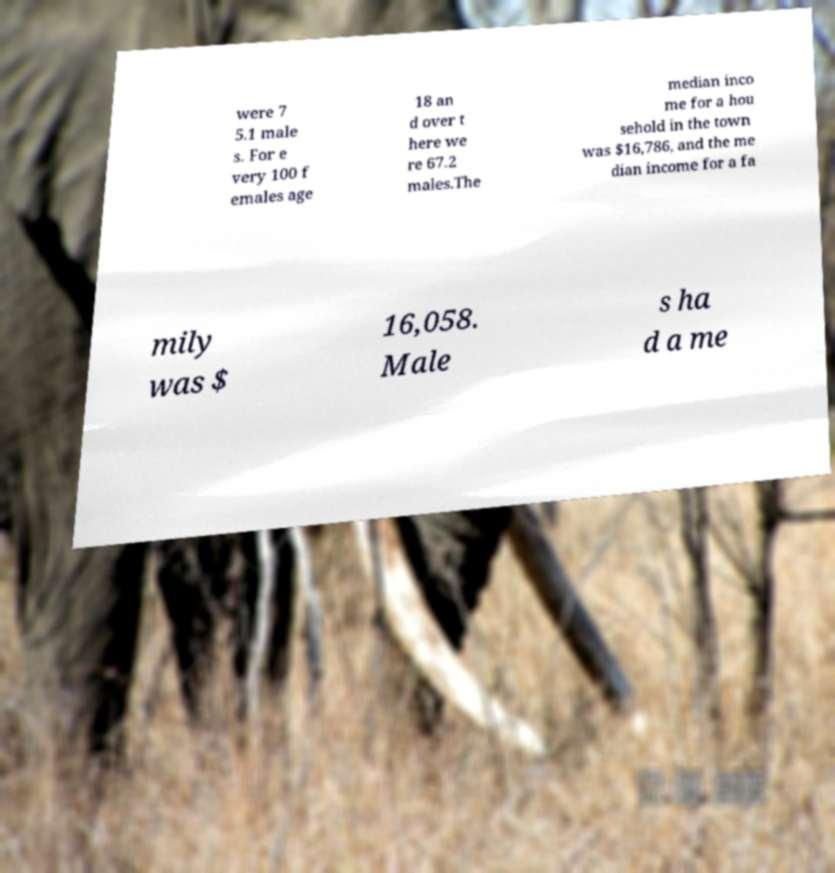Could you extract and type out the text from this image? were 7 5.1 male s. For e very 100 f emales age 18 an d over t here we re 67.2 males.The median inco me for a hou sehold in the town was $16,786, and the me dian income for a fa mily was $ 16,058. Male s ha d a me 